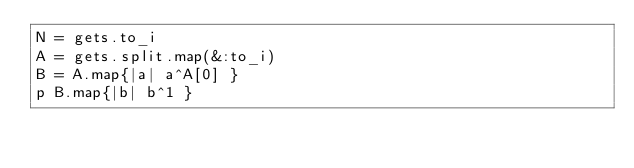<code> <loc_0><loc_0><loc_500><loc_500><_Ruby_>N = gets.to_i
A = gets.split.map(&:to_i)
B = A.map{|a| a^A[0] }
p B.map{|b| b^1 }
</code> 